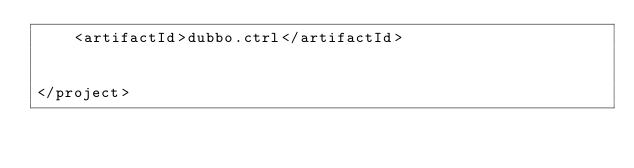<code> <loc_0><loc_0><loc_500><loc_500><_XML_>    <artifactId>dubbo.ctrl</artifactId>


</project></code> 